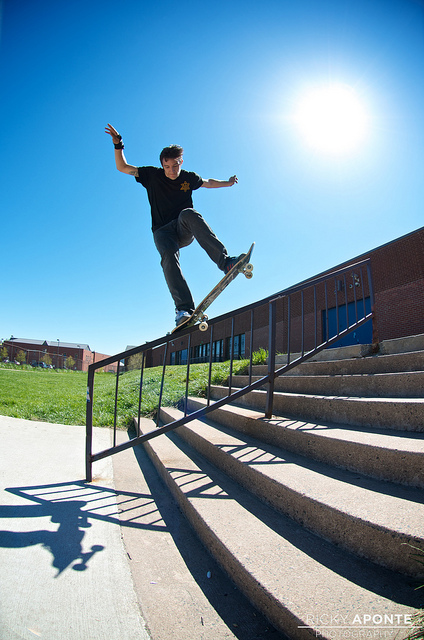Identify the text displayed in this image. RICKY APONTE 